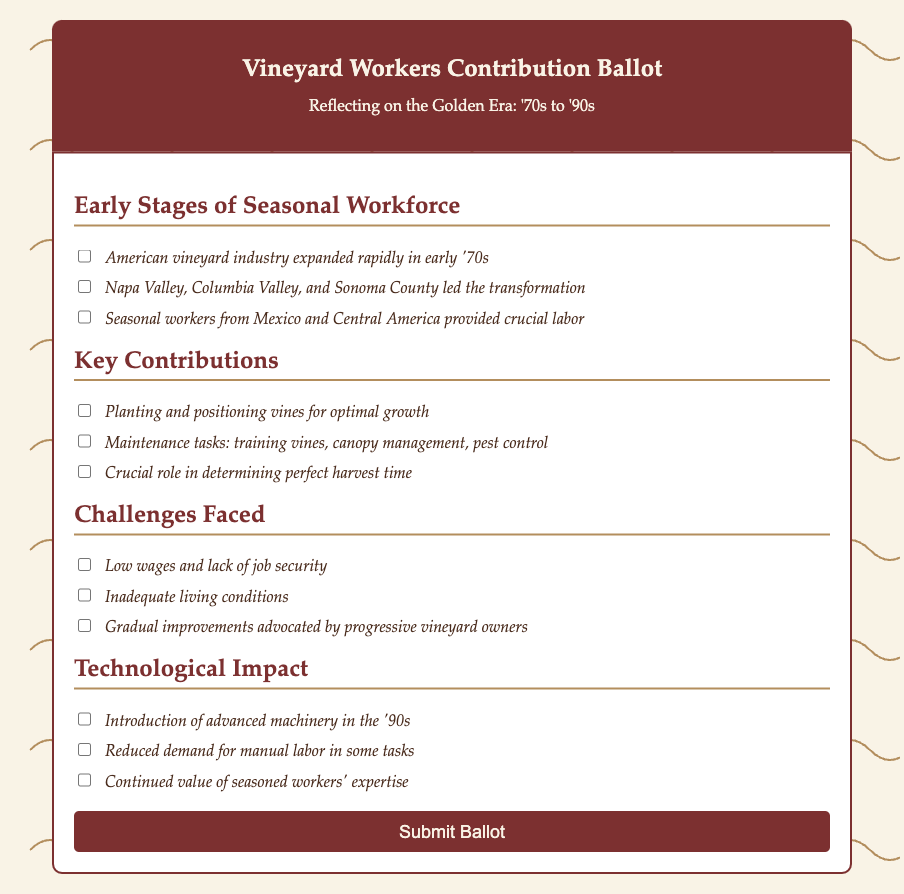What decade did the American vineyard industry expand rapidly? The document states that the American vineyard industry expanded rapidly in the early '70s.
Answer: '70s Which regions are mentioned as leading the transformation? The document lists Napa Valley, Columbia Valley, and Sonoma County as the regions that led the transformation.
Answer: Napa Valley, Columbia Valley, Sonoma County What type of labor was crucial from seasonal workers? The document indicates that seasonal workers from Mexico and Central America provided crucial labor for the vineyards.
Answer: Crucial labor What contributed to determining the perfect harvest time? The document reflects that a crucial role in determining perfect harvest time was executed by the seasonal workers.
Answer: Seasonal workers What were two challenges faced by vineyard workers? The document notes low wages, lack of job security, and inadequate living conditions as challenges faced by vineyard workers.
Answer: Low wages, inadequate living conditions In which decade was the introduction of advanced machinery noted? The document mentions the introduction of advanced machinery in the '90s.
Answer: '90s What impact did advanced machinery have on labor? The document states that there was a reduced demand for manual labor in some tasks due to advanced machinery.
Answer: Reduced demand What aspect of the relationship between seasoned workers and technology is emphasized? The document emphasizes the continued value of seasoned workers' expertise despite technological advancements.
Answer: Continued value of expertise What type of document is this? The document is a ballot meant for reflecting on the contributions of vineyard workers during a historical period.
Answer: Ballot 